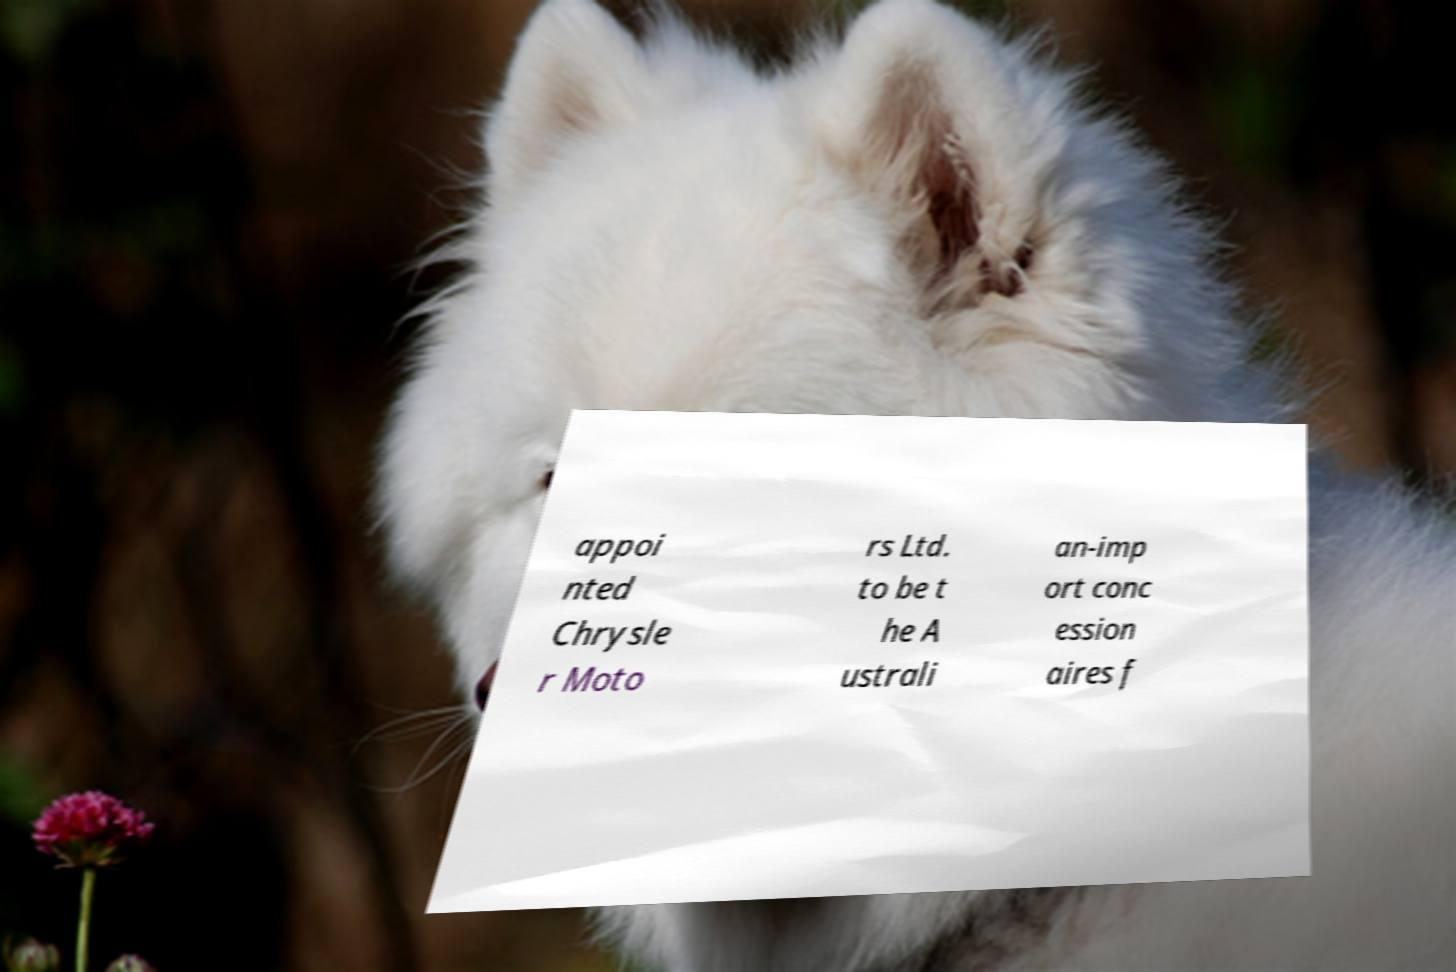Can you accurately transcribe the text from the provided image for me? appoi nted Chrysle r Moto rs Ltd. to be t he A ustrali an-imp ort conc ession aires f 